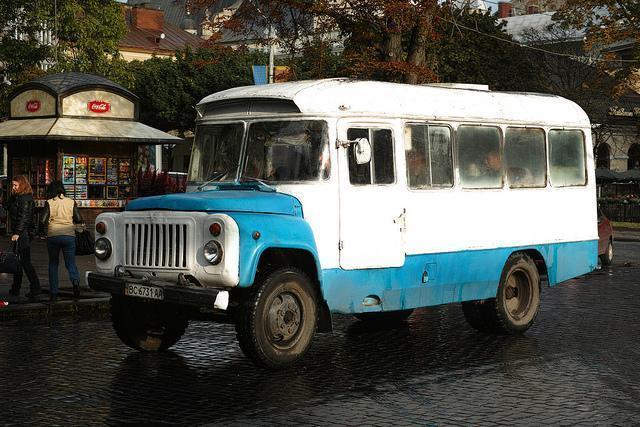How many people are visible?
Give a very brief answer. 2. How many bird legs can you see in this picture?
Give a very brief answer. 0. 